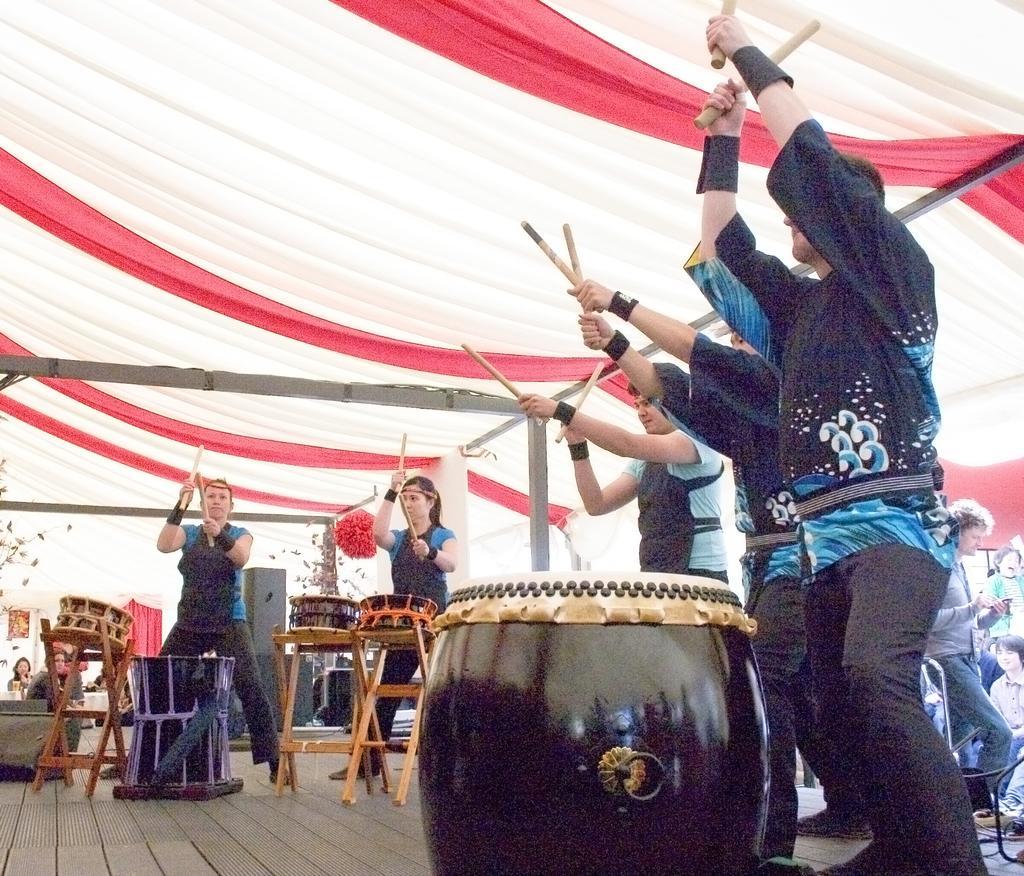Can you describe this image briefly? people are standing on the stage and playing drums. they are wearing blue and black t shirts and black pants. they are holding sticks in their hands. above them there is a red and white tent. people are surrounded by them. 